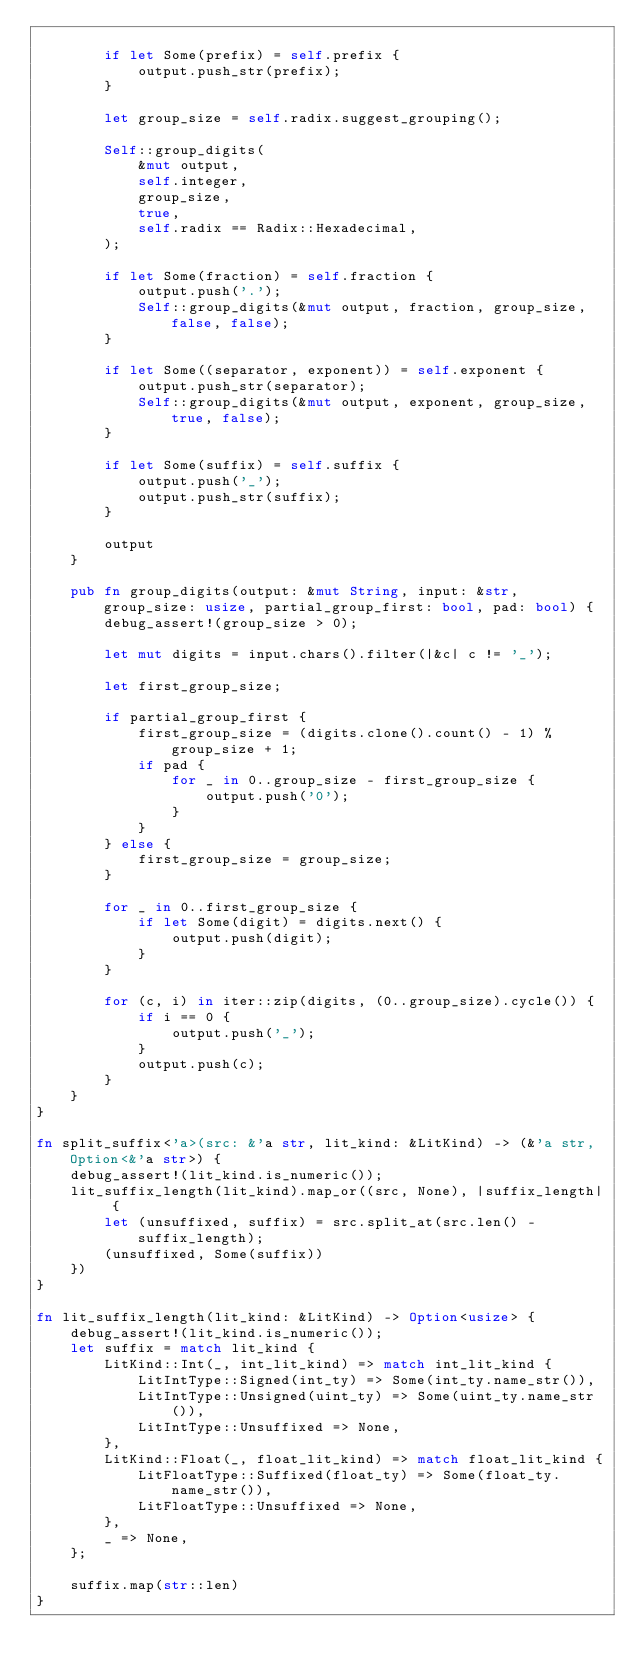<code> <loc_0><loc_0><loc_500><loc_500><_Rust_>
        if let Some(prefix) = self.prefix {
            output.push_str(prefix);
        }

        let group_size = self.radix.suggest_grouping();

        Self::group_digits(
            &mut output,
            self.integer,
            group_size,
            true,
            self.radix == Radix::Hexadecimal,
        );

        if let Some(fraction) = self.fraction {
            output.push('.');
            Self::group_digits(&mut output, fraction, group_size, false, false);
        }

        if let Some((separator, exponent)) = self.exponent {
            output.push_str(separator);
            Self::group_digits(&mut output, exponent, group_size, true, false);
        }

        if let Some(suffix) = self.suffix {
            output.push('_');
            output.push_str(suffix);
        }

        output
    }

    pub fn group_digits(output: &mut String, input: &str, group_size: usize, partial_group_first: bool, pad: bool) {
        debug_assert!(group_size > 0);

        let mut digits = input.chars().filter(|&c| c != '_');

        let first_group_size;

        if partial_group_first {
            first_group_size = (digits.clone().count() - 1) % group_size + 1;
            if pad {
                for _ in 0..group_size - first_group_size {
                    output.push('0');
                }
            }
        } else {
            first_group_size = group_size;
        }

        for _ in 0..first_group_size {
            if let Some(digit) = digits.next() {
                output.push(digit);
            }
        }

        for (c, i) in iter::zip(digits, (0..group_size).cycle()) {
            if i == 0 {
                output.push('_');
            }
            output.push(c);
        }
    }
}

fn split_suffix<'a>(src: &'a str, lit_kind: &LitKind) -> (&'a str, Option<&'a str>) {
    debug_assert!(lit_kind.is_numeric());
    lit_suffix_length(lit_kind).map_or((src, None), |suffix_length| {
        let (unsuffixed, suffix) = src.split_at(src.len() - suffix_length);
        (unsuffixed, Some(suffix))
    })
}

fn lit_suffix_length(lit_kind: &LitKind) -> Option<usize> {
    debug_assert!(lit_kind.is_numeric());
    let suffix = match lit_kind {
        LitKind::Int(_, int_lit_kind) => match int_lit_kind {
            LitIntType::Signed(int_ty) => Some(int_ty.name_str()),
            LitIntType::Unsigned(uint_ty) => Some(uint_ty.name_str()),
            LitIntType::Unsuffixed => None,
        },
        LitKind::Float(_, float_lit_kind) => match float_lit_kind {
            LitFloatType::Suffixed(float_ty) => Some(float_ty.name_str()),
            LitFloatType::Unsuffixed => None,
        },
        _ => None,
    };

    suffix.map(str::len)
}
</code> 